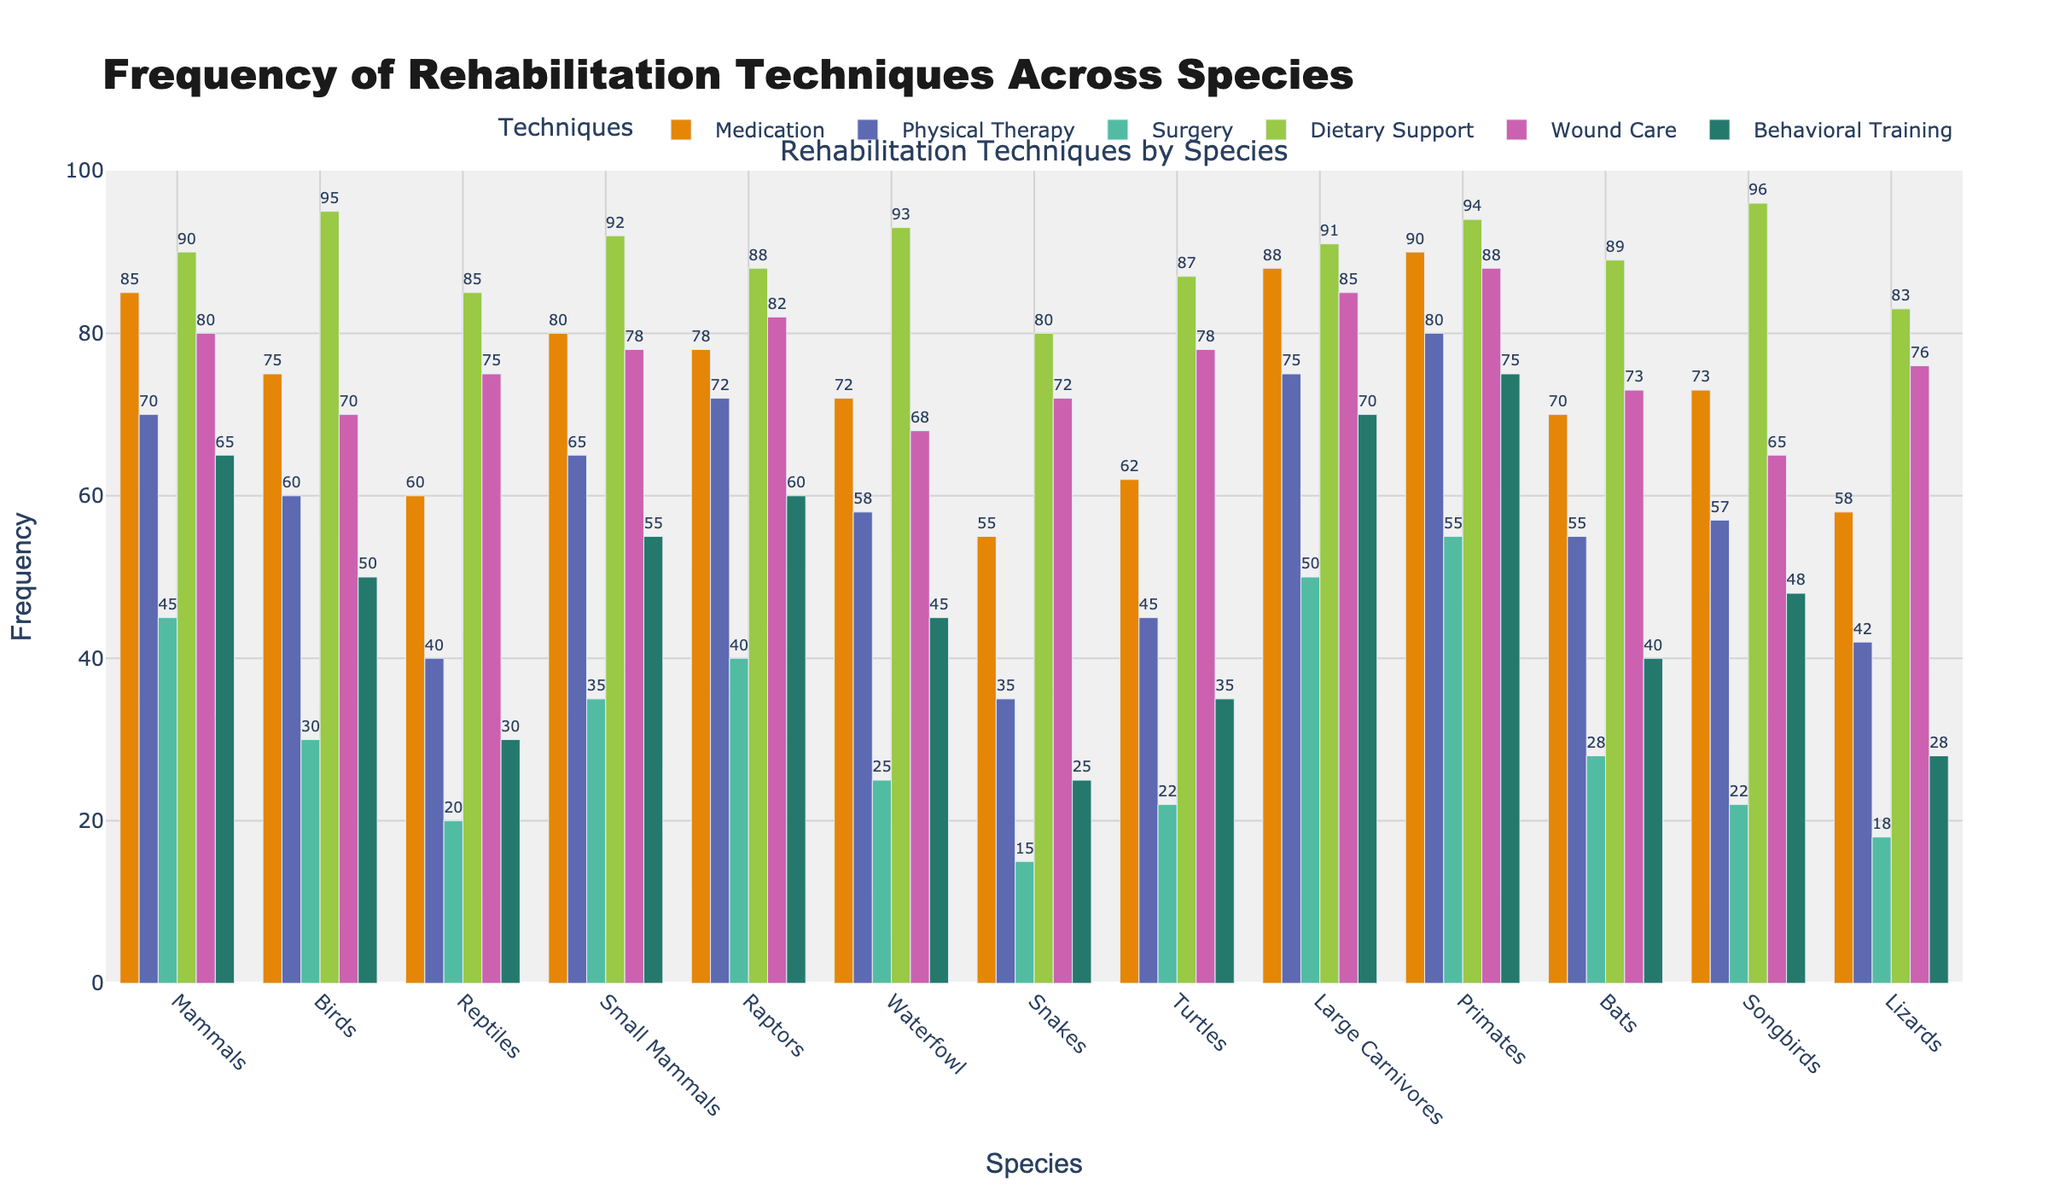What is the most frequently used rehabilitation technique for mammals? Looking at the bar heights for mammals, the highest bar represents dietary support.
Answer: Dietary support Which species has the highest frequency for surgery? By inspecting the heights of the bars in the surgery group for each species, we find that primates have the tallest bar.
Answer: Primates Compare the usage of medication between raptors and songbirds. Which species uses it more frequently? Reading the bar heights for medication in raptors and songbirds, we see raptors have a higher bar.
Answer: Raptors What is the least frequently used rehabilitation technique for reptiles? Observing the bar heights for each technique in reptiles, the shortest bar is for surgery.
Answer: Surgery Among all species, which one has the highest frequency of wound care? By comparing the bar heights for wound care across all species, large carnivores have the highest bar.
Answer: Large carnivores How does the frequency of physical therapy for mammals compare to reptiles? The bar for physical therapy in mammals is much taller than the one for reptiles, indicating higher frequency.
Answer: Mammals have higher frequency Sum the frequencies of dietary support and behavioral training for birds. The frequency for dietary support in birds is 95, and for behavioral training, it is 50. Adding these gives 95 + 50 = 145.
Answer: 145 What is the difference in the frequency of medication between bats and turtles? The frequency of medication for bats is 70, and for turtles, it is 62. The difference is 70 - 62 = 8.
Answer: 8 Identify the species with the least frequent use of physical therapy. Among all species, snakes have the lowest bar for physical therapy.
Answer: Snakes What's the average frequency of all rehabilitation techniques for songbirds? The frequencies are medication (73), physical therapy (57), surgery (22), dietary support (96), wound care (65), and behavioral training (48). Summing these: 73 + 57 + 22 + 96 + 65 + 48 = 361. Dividing by 6 gives 361 / 6 = 60.17.
Answer: 60.17 